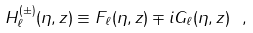Convert formula to latex. <formula><loc_0><loc_0><loc_500><loc_500>H _ { \ell } ^ { ( \pm ) } ( \eta , z ) \equiv F _ { \ell } ( \eta , z ) \mp i G _ { \ell } ( \eta , z ) \ ,</formula> 